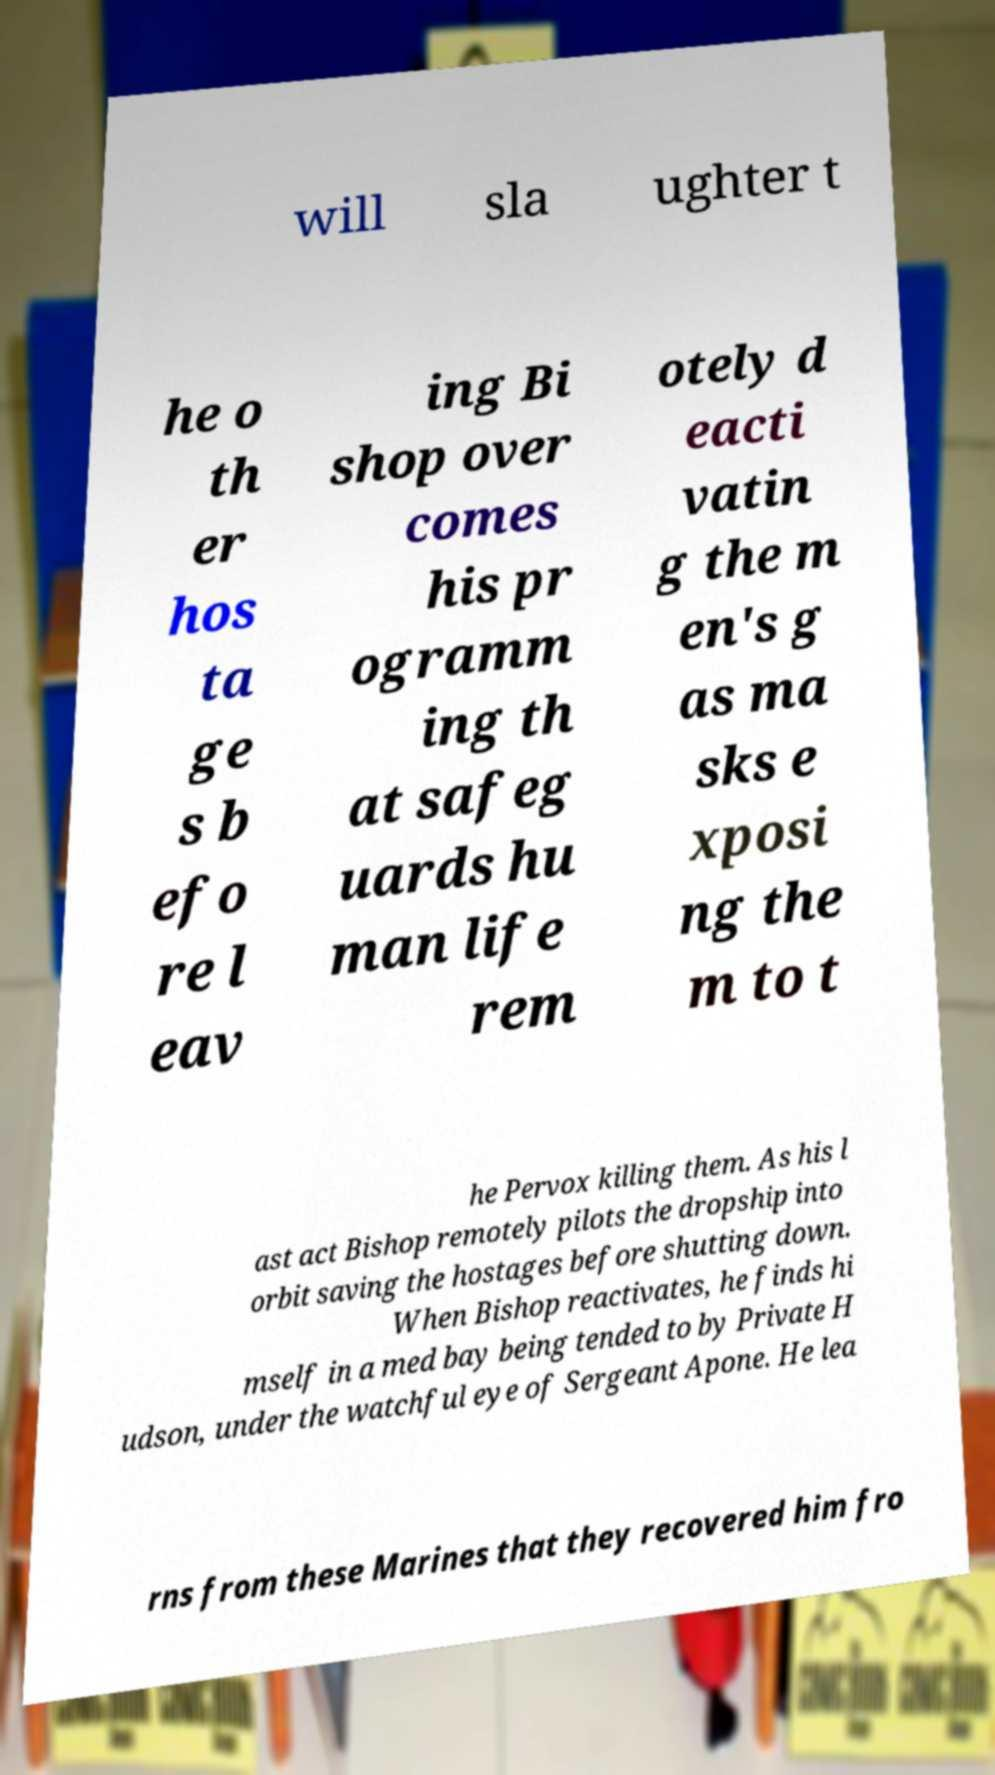Can you read and provide the text displayed in the image?This photo seems to have some interesting text. Can you extract and type it out for me? will sla ughter t he o th er hos ta ge s b efo re l eav ing Bi shop over comes his pr ogramm ing th at safeg uards hu man life rem otely d eacti vatin g the m en's g as ma sks e xposi ng the m to t he Pervox killing them. As his l ast act Bishop remotely pilots the dropship into orbit saving the hostages before shutting down. When Bishop reactivates, he finds hi mself in a med bay being tended to by Private H udson, under the watchful eye of Sergeant Apone. He lea rns from these Marines that they recovered him fro 